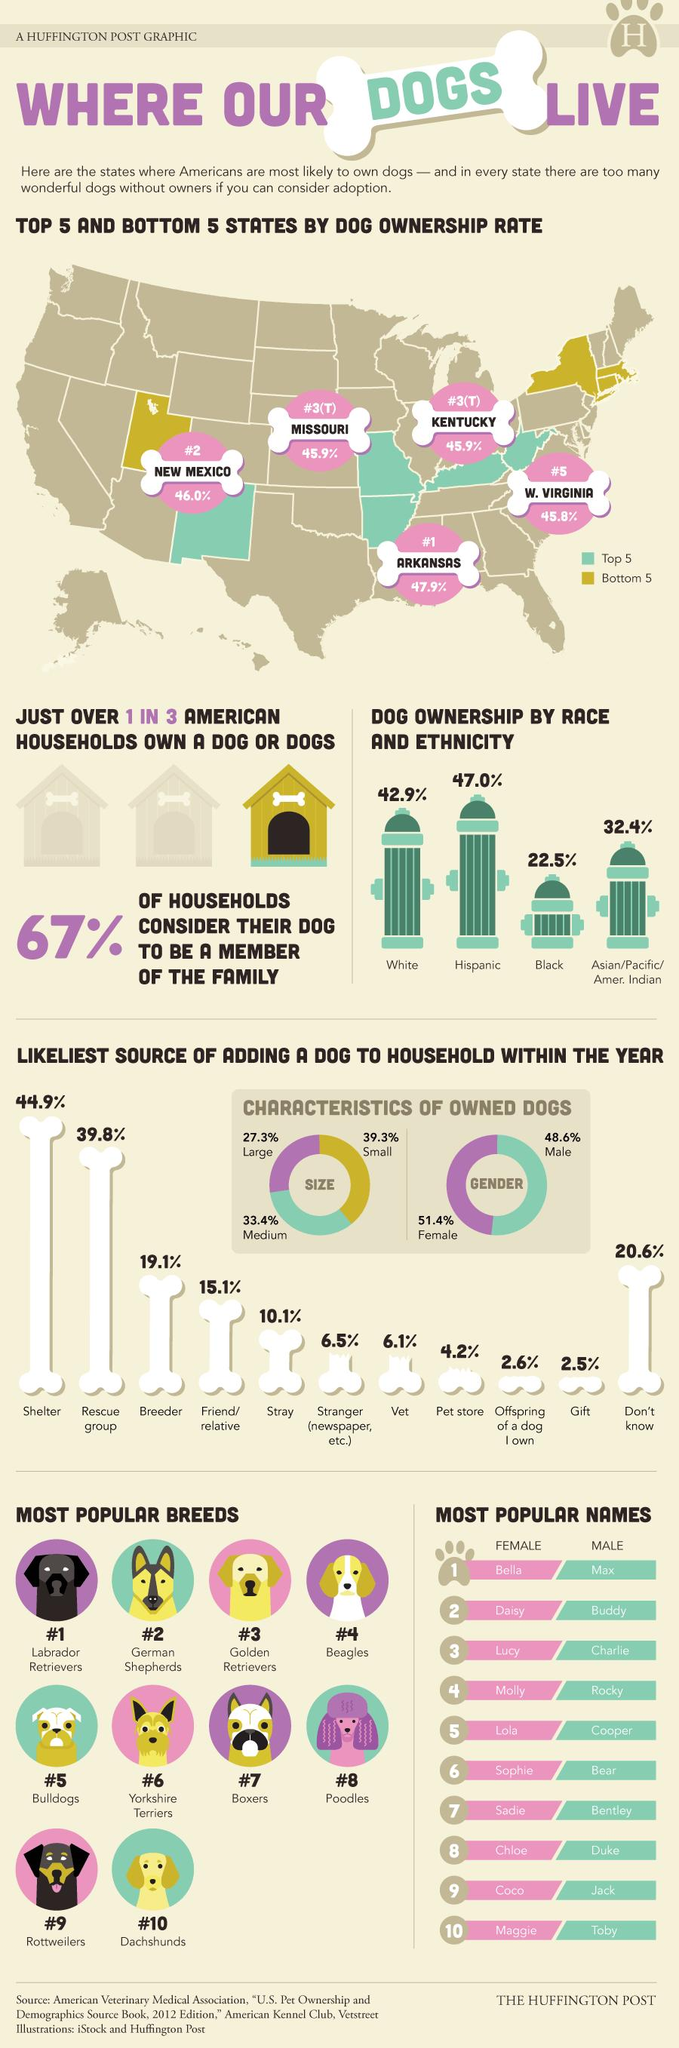Specify some key components in this picture. The state of Arkansas is home to the largest number of dogs in the United States. According to a study, Hispanic Americans own more dogs in the United States than any other race or ethnicity. According to data, black individuals own the least number of dogs in America. Labrador Retrievers are the most popular dog breed in America, according to a recent survey. Dachshunds are the least popular dog breed across America. 